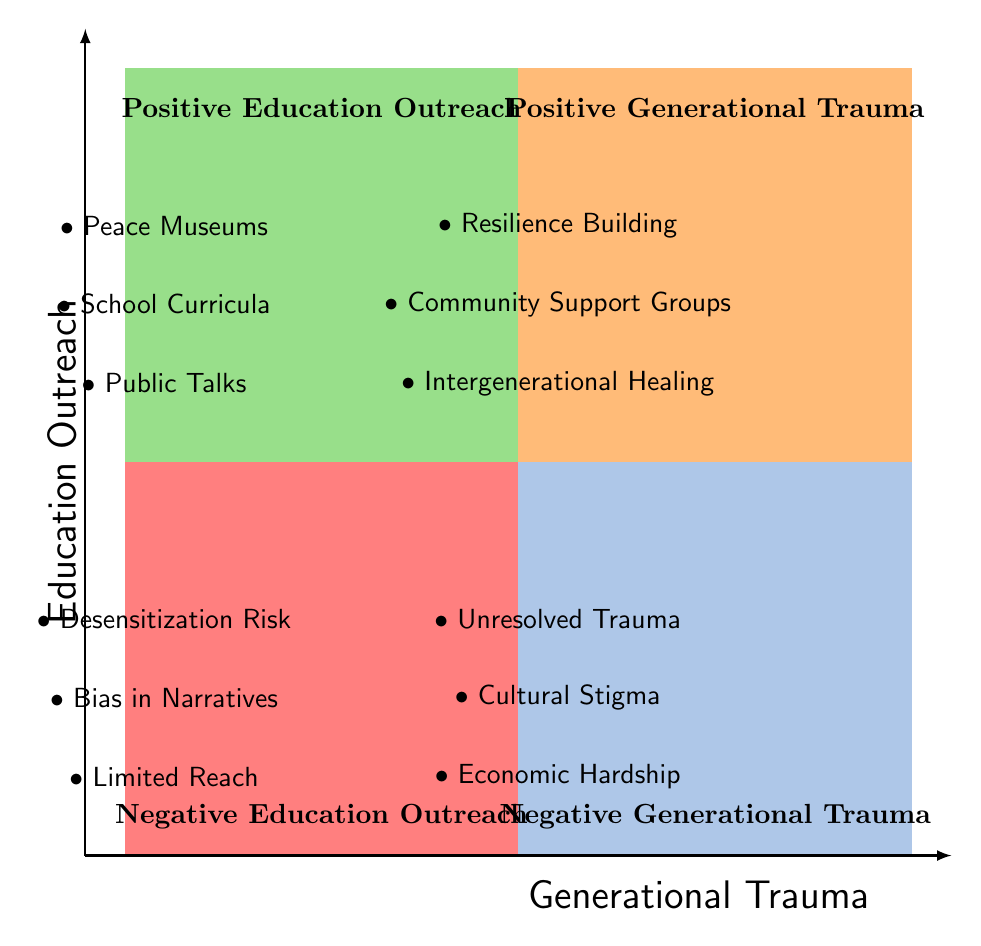What elements are listed under Positive Education Outreach? Positive Education Outreach includes three elements: Peace Museums, School Curricula, and Public Talks. These are clearly stated in the upper-left quadrant of the diagram.
Answer: Peace Museums, School Curricula, Public Talks How many elements are under Negative Generational Trauma? There are three elements listed under Negative Generational Trauma, which includes Unresolved Trauma, Cultural Stigma, and Economic Hardship. This can be found in the lower-right quadrant.
Answer: 3 What does the Positive Generational Trauma quadrant emphasize? The Positive Generational Trauma quadrant emphasizes resilience and emotional support for the children of survivors, featuring elements like Resilience Building, Community Support Groups, and Intergenerational Healing. This information is in the upper-right quadrant.
Answer: Resilience and emotional support Which element in Negative Education Outreach refers to the potential emotional impact issue? The element in Negative Education Outreach that refers to emotional impact is Desensitization Risk, indicating overexposure could dilute the emotional effect of the education provided. This is located in the lower-left quadrant.
Answer: Desensitization Risk How is the relationship between education outreach and generational trauma depicted in the diagram? The diagram organizes education outreach and generational trauma into four quadrants, highlighting the positive and negative effects of each on communities. Positive Education Outreach and Positive Generational Trauma are paired in the upper quadrants, while Negative Education Outreach and Negative Generational Trauma are paired in the lower quadrants, visually contrasting the two themes.
Answer: Positive and negative effects What is the element under Positive Education Outreach that enhances community awareness? The element under Positive Education Outreach that enhances community awareness is Peace Museums, as they serve to promote education about nuclear warfare and its consequences. This is indicated in the upper-left quadrant.
Answer: Peace Museums 